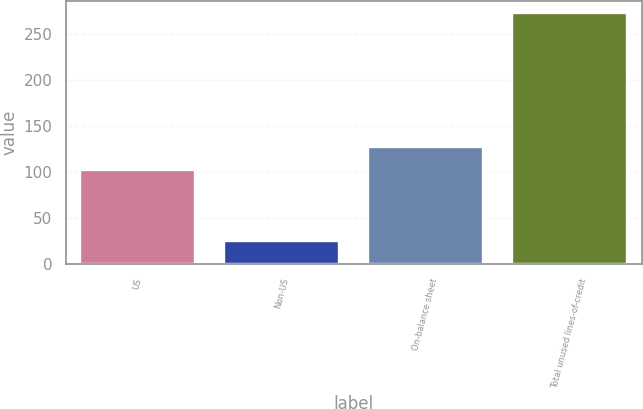Convert chart to OTSL. <chart><loc_0><loc_0><loc_500><loc_500><bar_chart><fcel>US<fcel>Non-US<fcel>On-balance sheet<fcel>Total unused lines-of-credit<nl><fcel>102<fcel>25<fcel>127<fcel>273<nl></chart> 